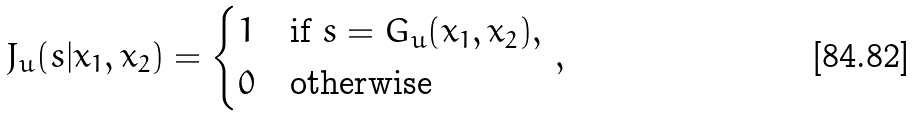<formula> <loc_0><loc_0><loc_500><loc_500>J _ { u } ( s | x _ { 1 } , x _ { 2 } ) = \begin{cases} 1 & \text {if $s=G_{u}(x_{1},x_{2})$} , \\ 0 & \text {otherwise} \end{cases} \, ,</formula> 